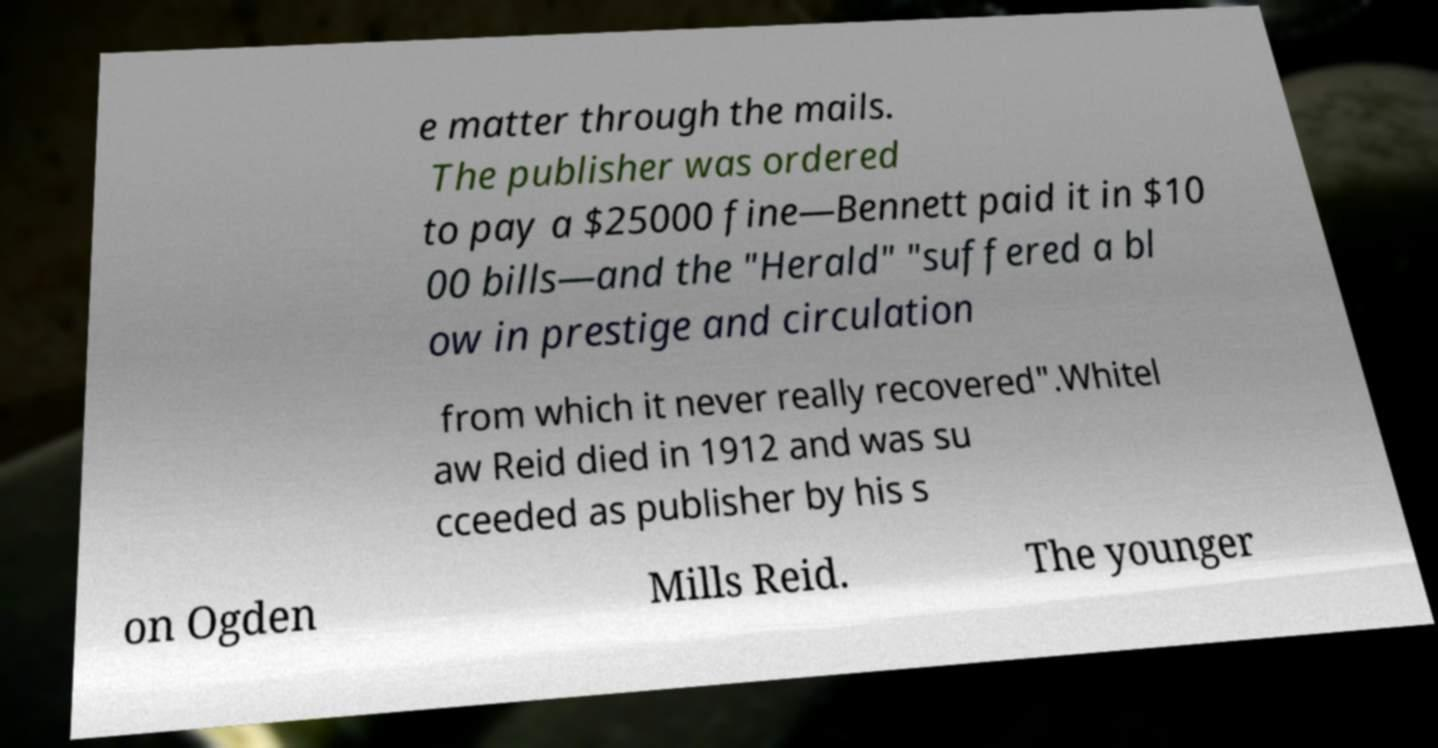I need the written content from this picture converted into text. Can you do that? e matter through the mails. The publisher was ordered to pay a $25000 fine—Bennett paid it in $10 00 bills—and the "Herald" "suffered a bl ow in prestige and circulation from which it never really recovered".Whitel aw Reid died in 1912 and was su cceeded as publisher by his s on Ogden Mills Reid. The younger 